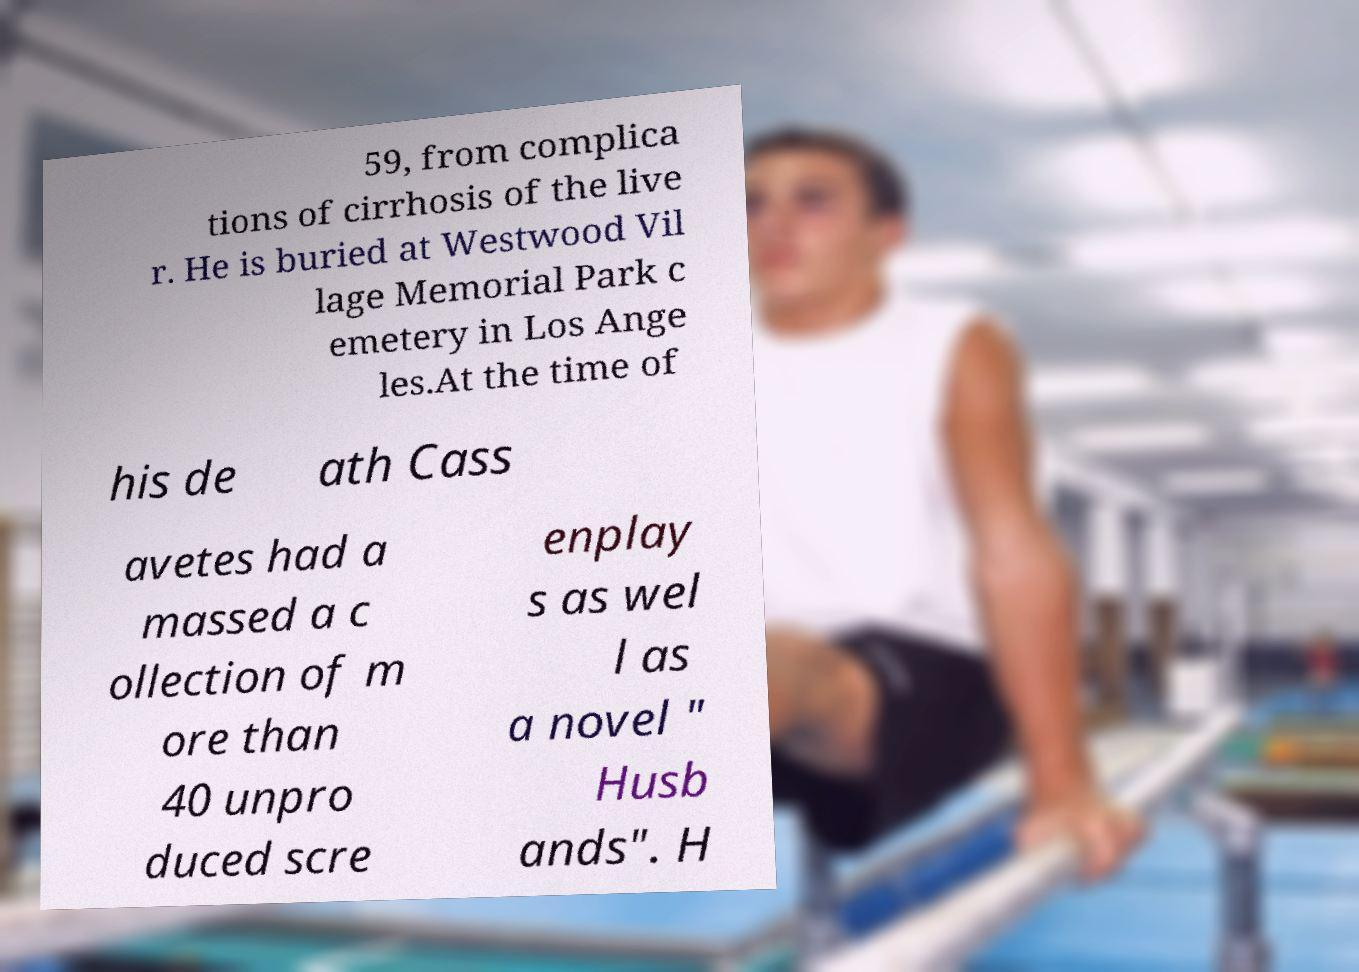Please identify and transcribe the text found in this image. 59, from complica tions of cirrhosis of the live r. He is buried at Westwood Vil lage Memorial Park c emetery in Los Ange les.At the time of his de ath Cass avetes had a massed a c ollection of m ore than 40 unpro duced scre enplay s as wel l as a novel " Husb ands". H 